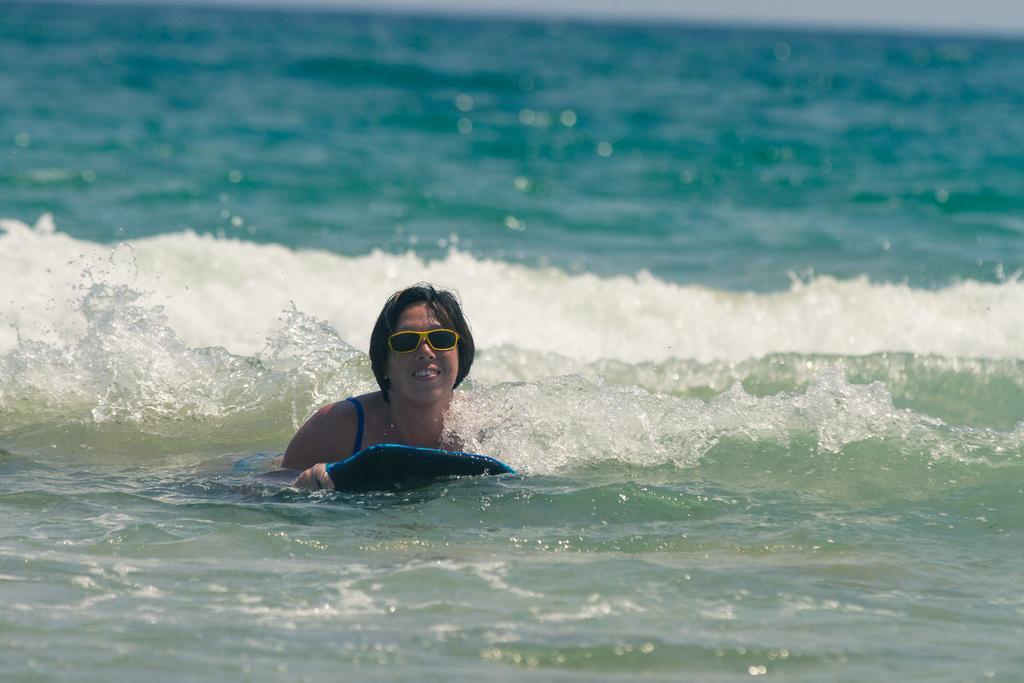Can you describe this image briefly? In this image we can see a woman wearing glasses is floating in the water using an object. The background of the image is blurred. 